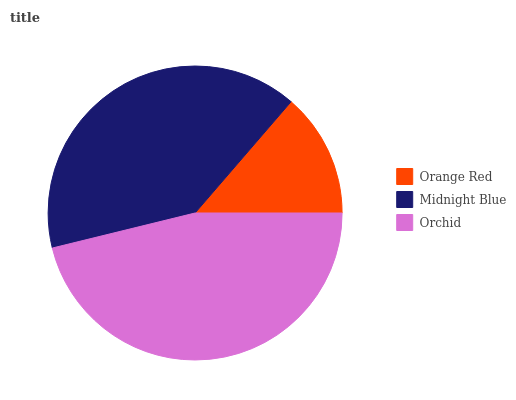Is Orange Red the minimum?
Answer yes or no. Yes. Is Orchid the maximum?
Answer yes or no. Yes. Is Midnight Blue the minimum?
Answer yes or no. No. Is Midnight Blue the maximum?
Answer yes or no. No. Is Midnight Blue greater than Orange Red?
Answer yes or no. Yes. Is Orange Red less than Midnight Blue?
Answer yes or no. Yes. Is Orange Red greater than Midnight Blue?
Answer yes or no. No. Is Midnight Blue less than Orange Red?
Answer yes or no. No. Is Midnight Blue the high median?
Answer yes or no. Yes. Is Midnight Blue the low median?
Answer yes or no. Yes. Is Orchid the high median?
Answer yes or no. No. Is Orange Red the low median?
Answer yes or no. No. 